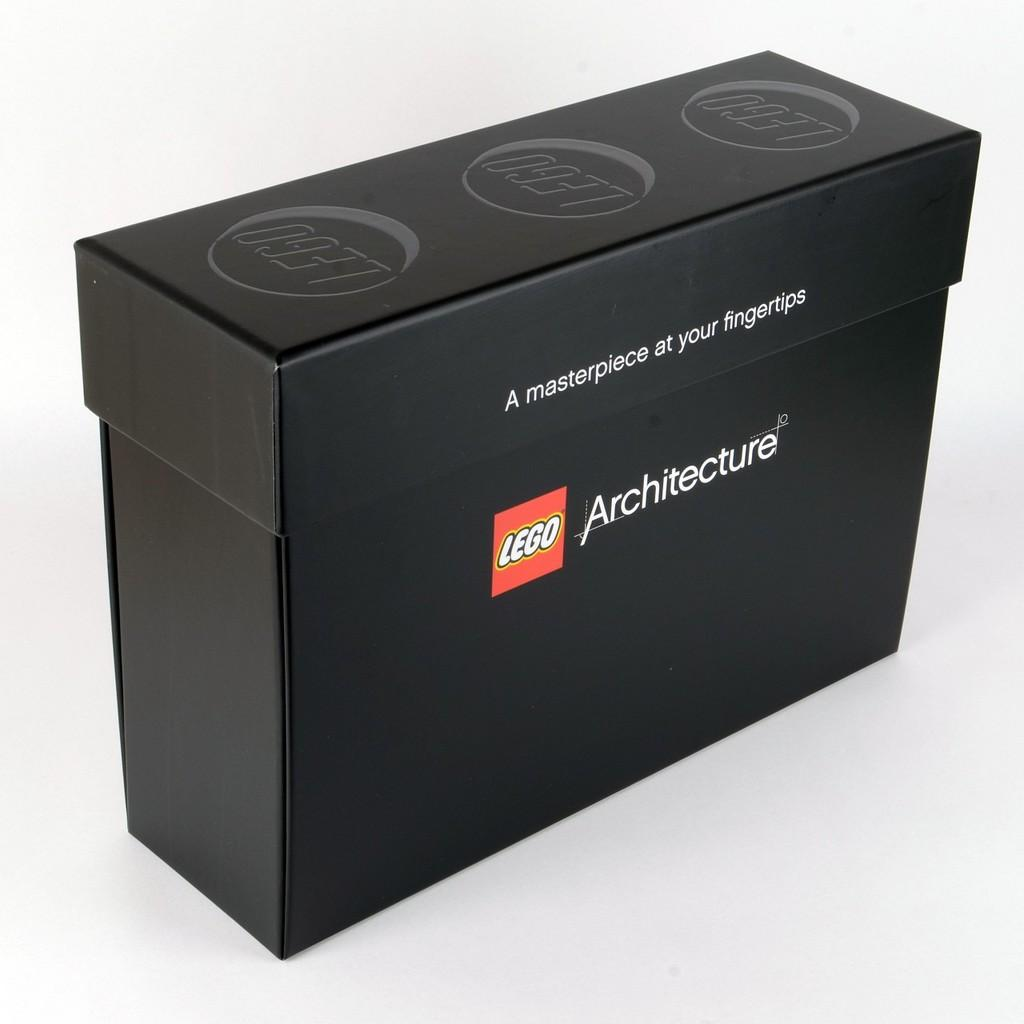Provide a one-sentence caption for the provided image. A black box of legos with a white background. 